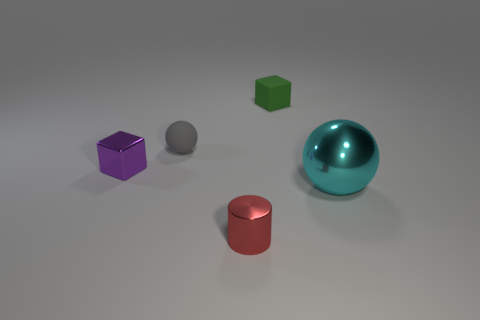Add 1 gray cubes. How many objects exist? 6 Subtract all balls. How many objects are left? 3 Add 5 large things. How many large things are left? 6 Add 3 tiny red shiny things. How many tiny red shiny things exist? 4 Subtract 0 gray blocks. How many objects are left? 5 Subtract all tiny purple metallic objects. Subtract all metal spheres. How many objects are left? 3 